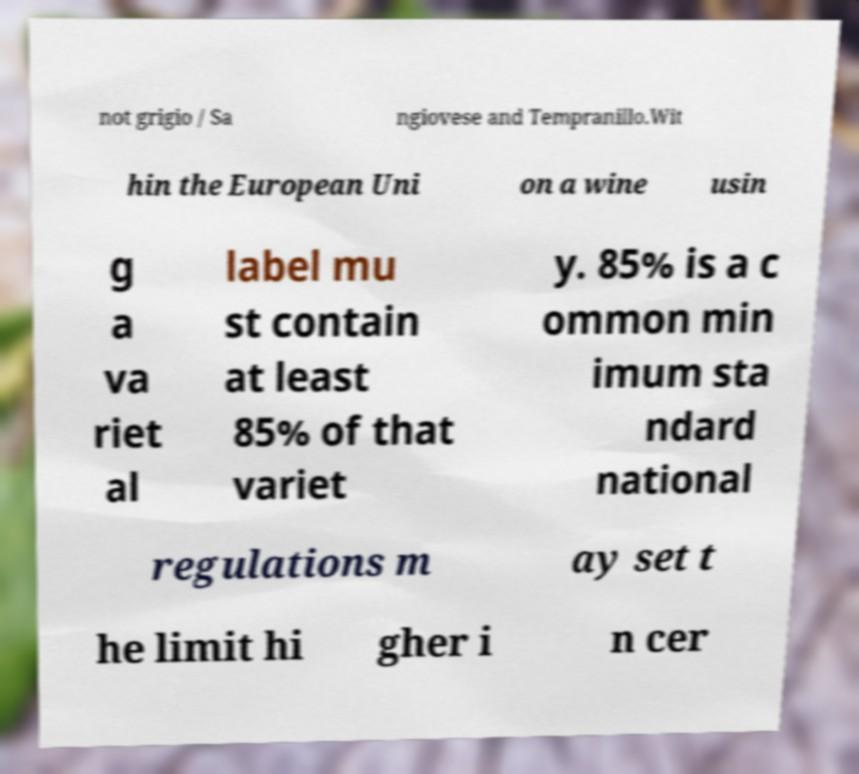What messages or text are displayed in this image? I need them in a readable, typed format. not grigio / Sa ngiovese and Tempranillo.Wit hin the European Uni on a wine usin g a va riet al label mu st contain at least 85% of that variet y. 85% is a c ommon min imum sta ndard national regulations m ay set t he limit hi gher i n cer 